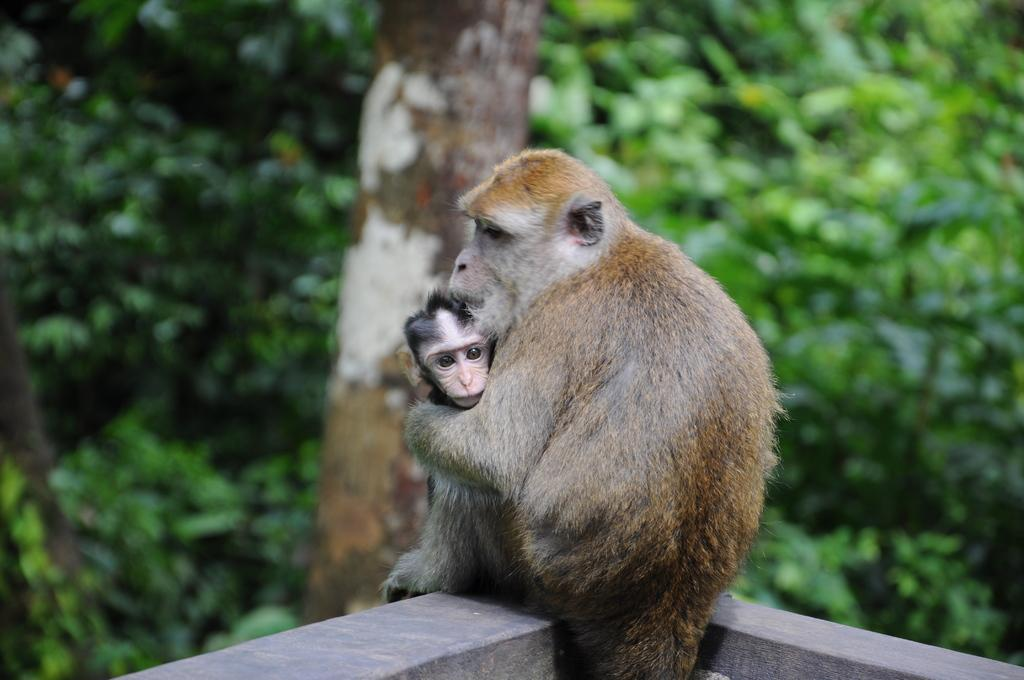What is the main subject of the image? The main subject of the image is a mother monkey. What is the mother monkey doing in the image? The mother monkey is holding a baby monkey in her lap. Can you describe the background of the image? The background of the image is blurred. What type of hair product is visible in the image? There is no hair product present in the image. What unit of measurement is used to determine the size of the monkeys in the image? There is no unit of measurement mentioned or visible in the image. 